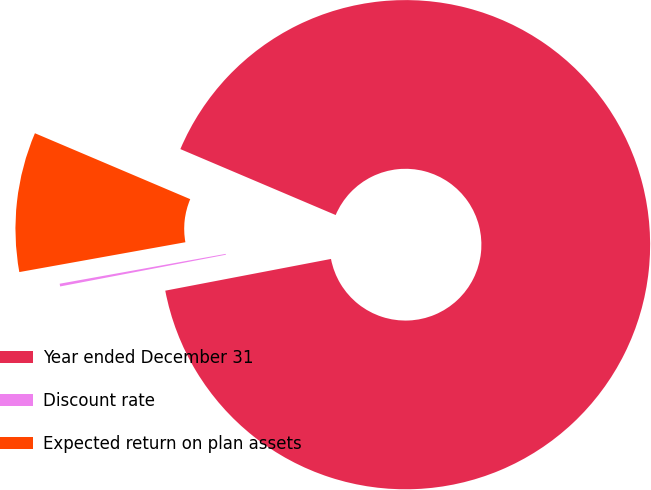Convert chart to OTSL. <chart><loc_0><loc_0><loc_500><loc_500><pie_chart><fcel>Year ended December 31<fcel>Discount rate<fcel>Expected return on plan assets<nl><fcel>90.6%<fcel>0.18%<fcel>9.22%<nl></chart> 